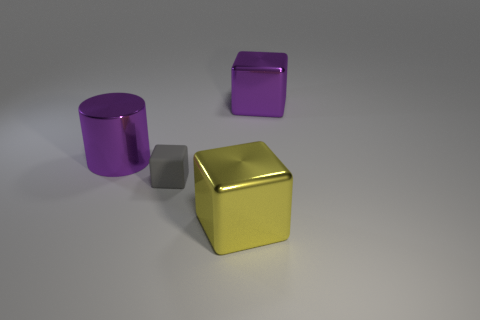Is there any other thing that is the same size as the purple block?
Give a very brief answer. Yes. What number of yellow objects have the same shape as the gray matte thing?
Your response must be concise. 1. There is a yellow metallic cube; are there any purple shiny objects to the left of it?
Keep it short and to the point. Yes. How many shiny things are either gray things or cyan things?
Provide a short and direct response. 0. How many metal cubes are in front of the small rubber block?
Keep it short and to the point. 1. Is there another metallic cube of the same size as the purple block?
Your response must be concise. Yes. Are there any large things that have the same color as the large cylinder?
Your answer should be very brief. Yes. What number of things are the same color as the metallic cylinder?
Ensure brevity in your answer.  1. There is a big cylinder; does it have the same color as the big metallic cube that is behind the tiny gray object?
Your response must be concise. Yes. How many objects are either big purple things or big shiny objects in front of the purple metallic cylinder?
Provide a succinct answer. 3. 